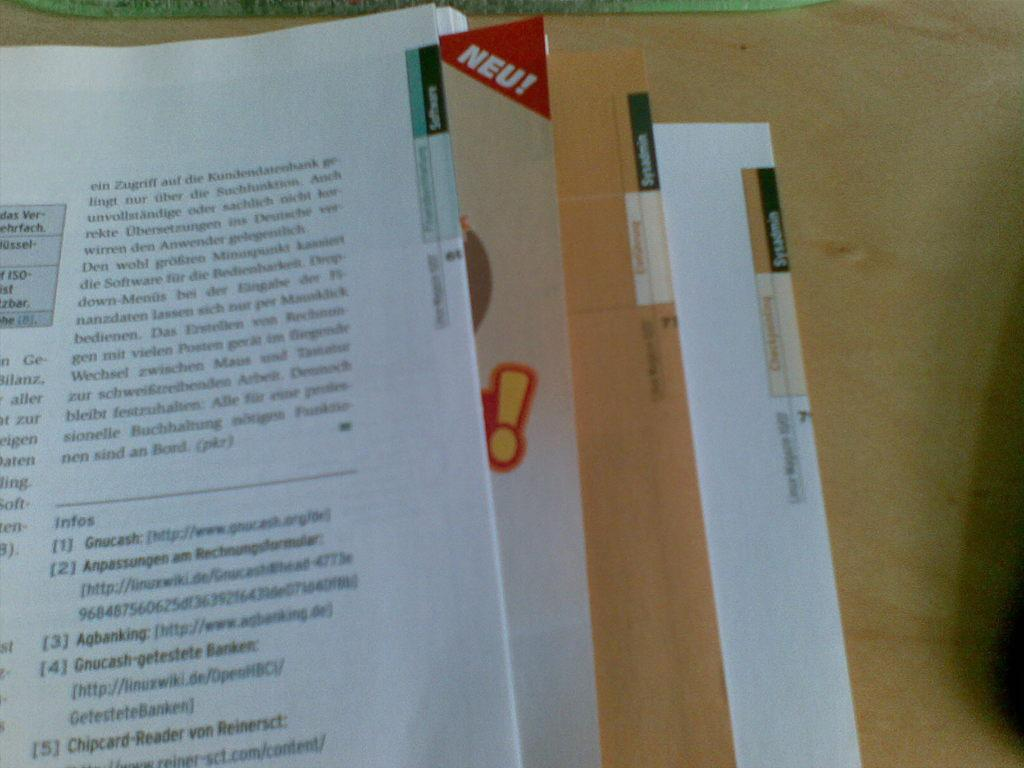<image>
Summarize the visual content of the image. the word neu that is at the top of a page 